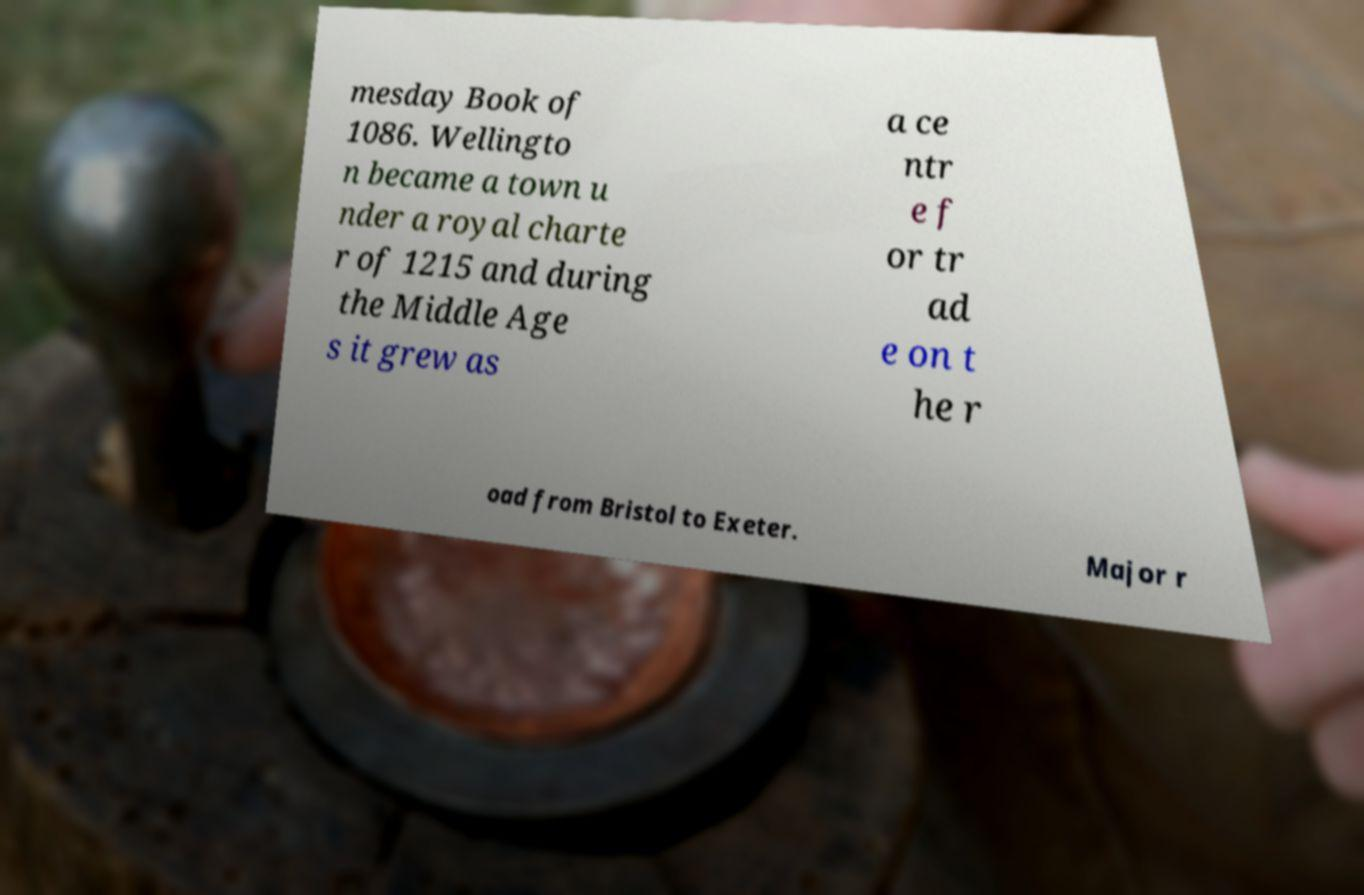Could you extract and type out the text from this image? mesday Book of 1086. Wellingto n became a town u nder a royal charte r of 1215 and during the Middle Age s it grew as a ce ntr e f or tr ad e on t he r oad from Bristol to Exeter. Major r 